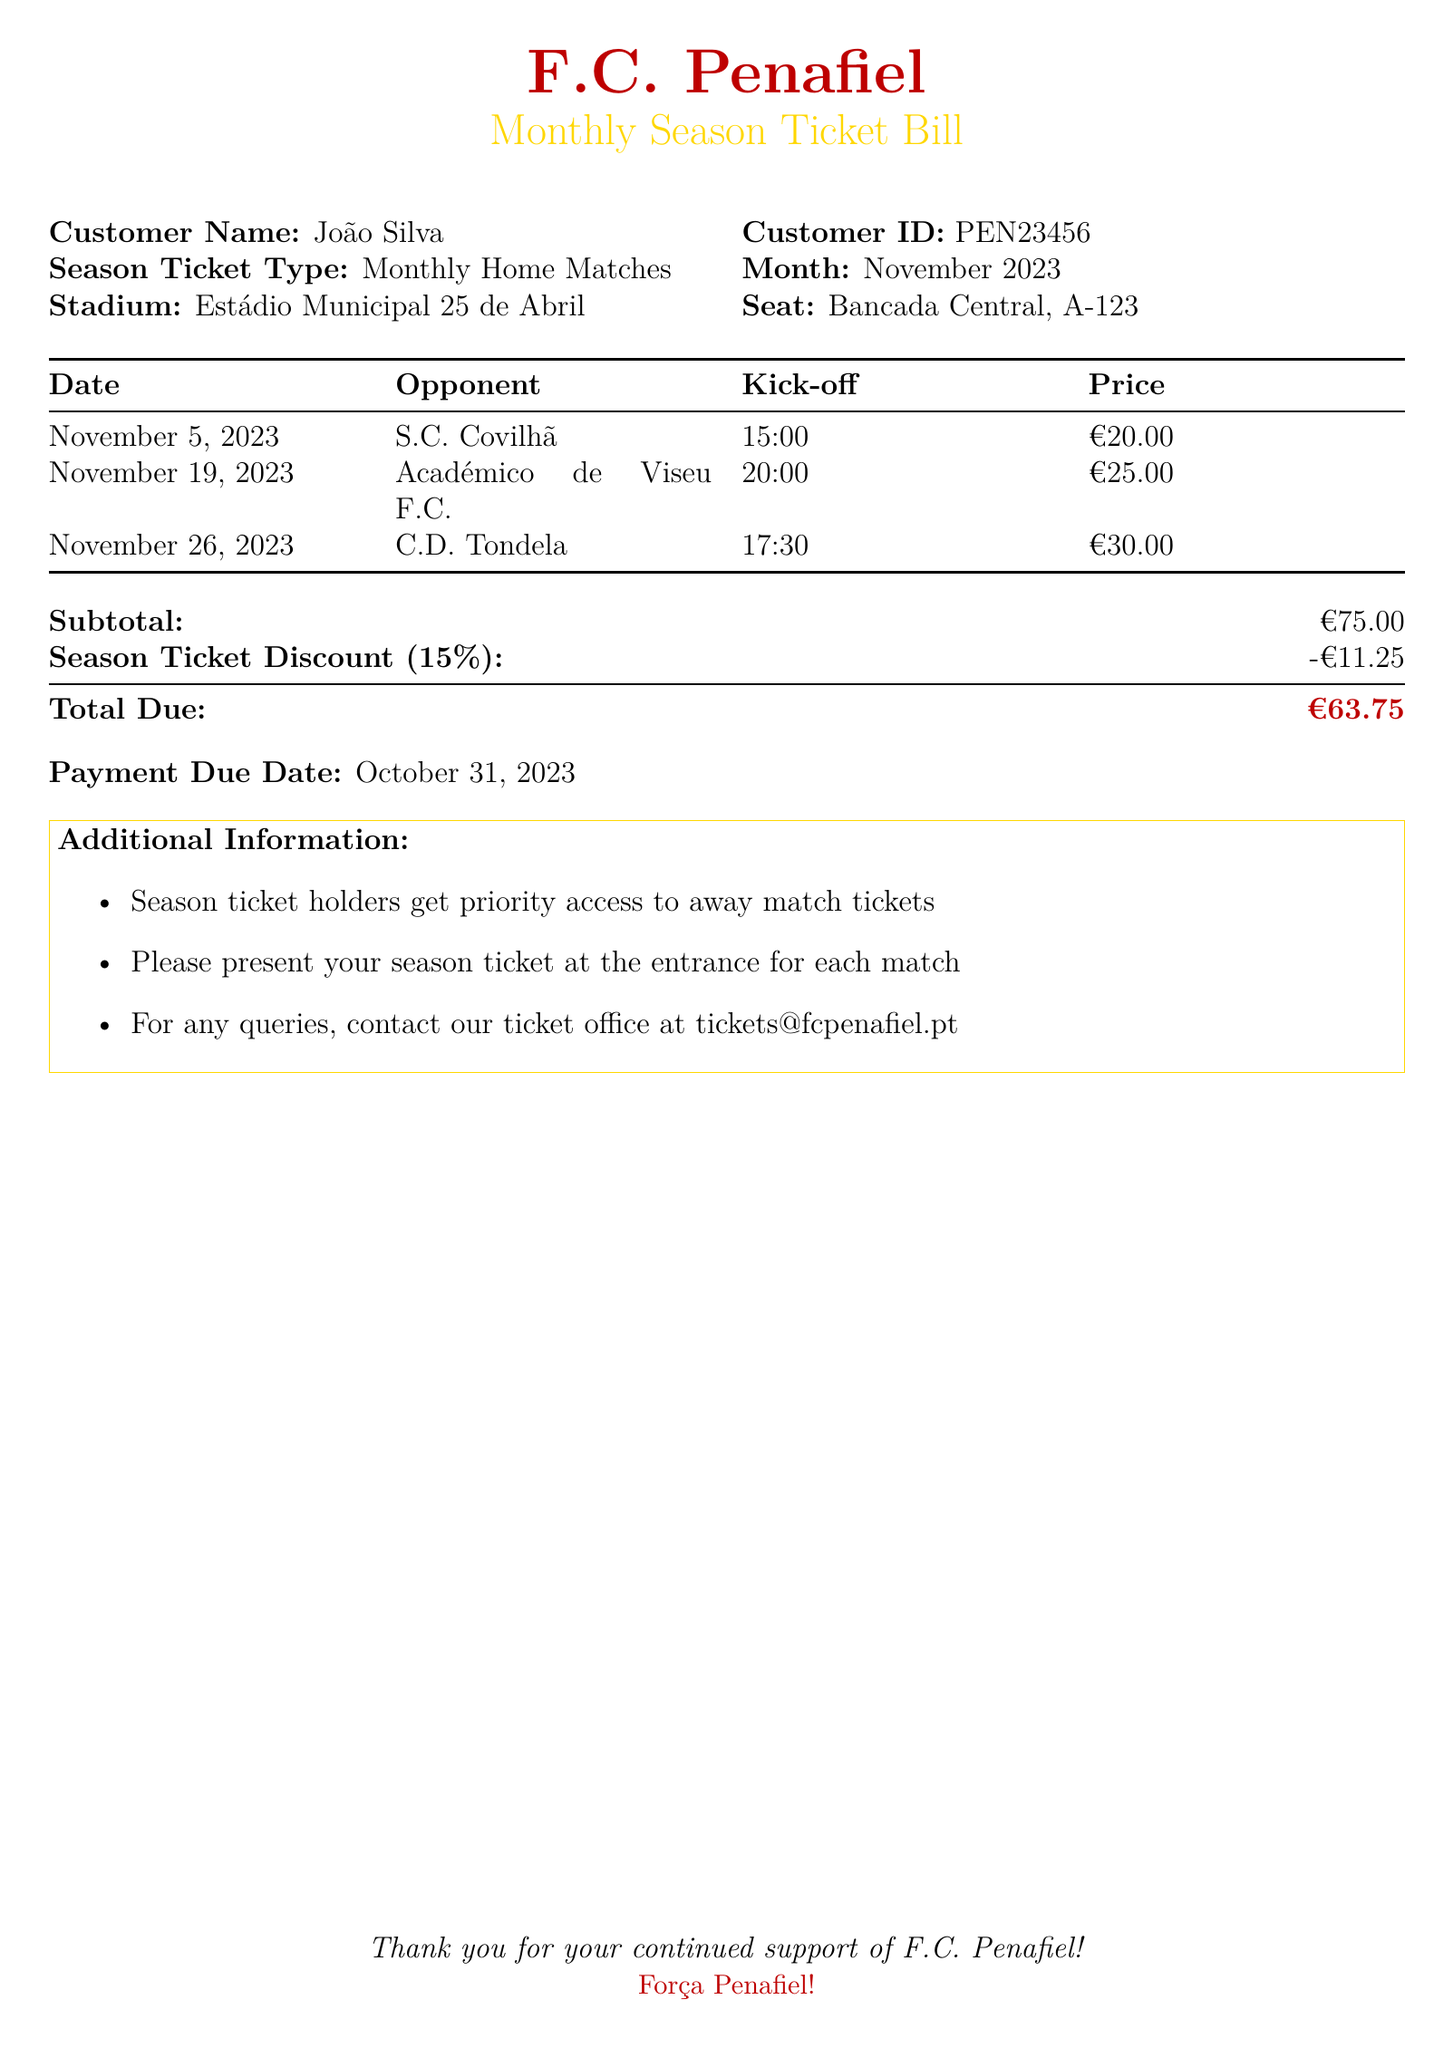What is the customer name? The customer name is provided in the document as João Silva.
Answer: João Silva What is the total due amount? The total due amount is stated at the bottom of the bill, which includes the subtotal and the season ticket discount.
Answer: €63.75 What is the kick-off time for the match against C.D. Tondela? The document lists the kick-off time for the match against C.D. Tondela as 17:30.
Answer: 17:30 How much is the season ticket discount? The discount applied to the season ticket is mentioned in the breakdown as -€11.25.
Answer: -€11.25 What is the venue for the matches? The venue where all the home matches will take place is stated in the document.
Answer: Estádio Municipal 25 de Abril What is the price of the match against Académico de Viseu F.C.? The document specifies the price for the match on November 19, 2023, as €25.00.
Answer: €25.00 How many matches are included in the monthly bill? The document lists three matches, indicating the number of home matches included for the month.
Answer: 3 What is the payment due date? The payment due date is explicitly mentioned in the document, stating when payment must be made.
Answer: October 31, 2023 What is the season ticket type? The type of season ticket mentioned in the document is Monthly Home Matches.
Answer: Monthly Home Matches 